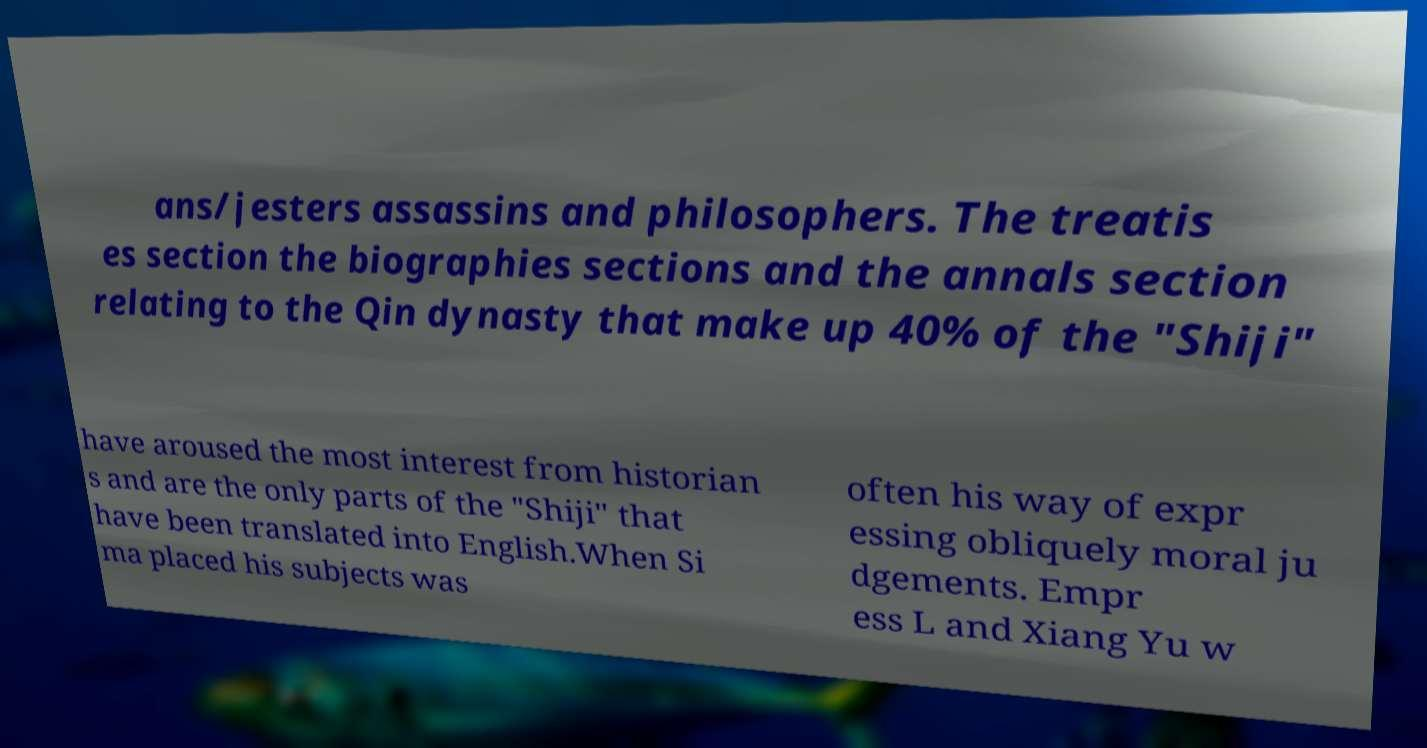Could you assist in decoding the text presented in this image and type it out clearly? ans/jesters assassins and philosophers. The treatis es section the biographies sections and the annals section relating to the Qin dynasty that make up 40% of the "Shiji" have aroused the most interest from historian s and are the only parts of the "Shiji" that have been translated into English.When Si ma placed his subjects was often his way of expr essing obliquely moral ju dgements. Empr ess L and Xiang Yu w 